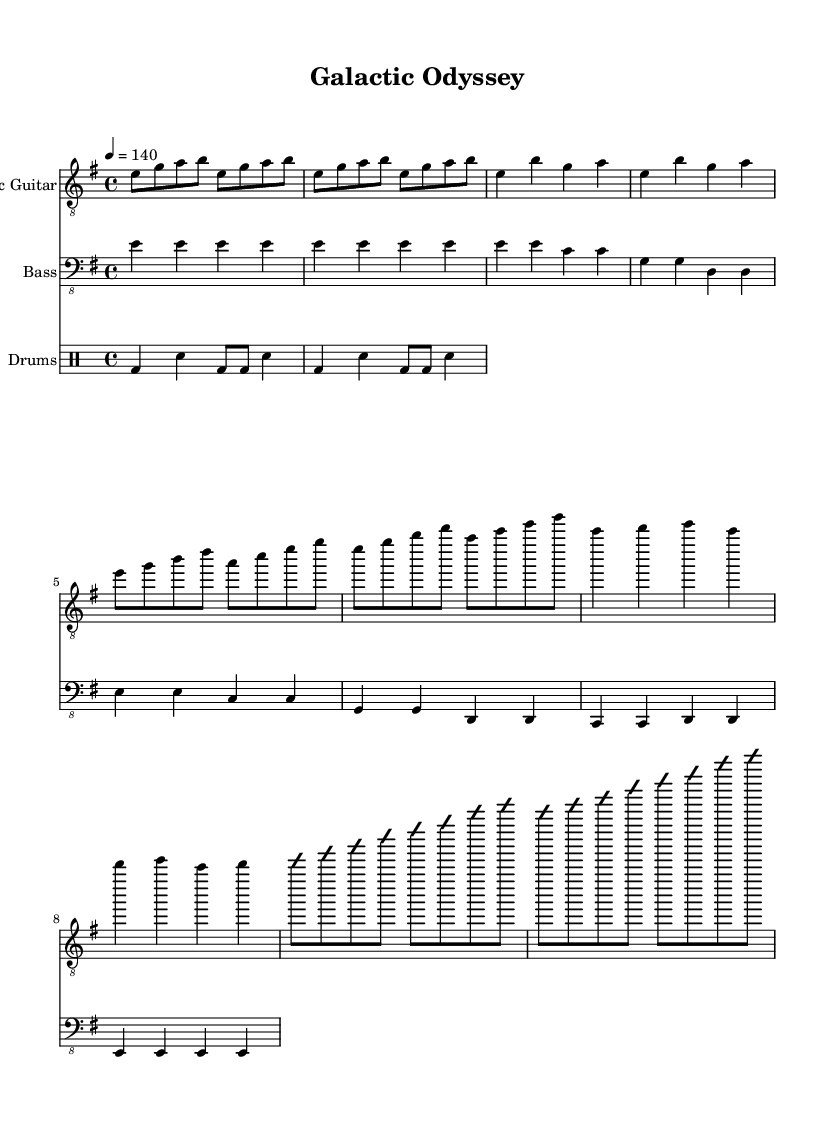What is the key signature of this music? The key is E minor, which is indicated by one sharp (F#) in the key signature.
Answer: E minor What is the time signature of this music? The time signature is found at the beginning of the music, showing 4 beats per measure, indicated by 4/4.
Answer: 4/4 What is the tempo marking for this piece? The tempo marking is indicated at the beginning with "4 = 140", meaning there are 140 beats per minute.
Answer: 140 How many measures are there in the chorus? The chorus includes two measures, as shown in the note representation provided.
Answer: 2 Which instrument primarily plays the melody? The electric guitar plays the melody throughout the piece, as indicated by the corresponding staff notation.
Answer: Electric Guitar What type of drum beat is used in the song? The drum pattern reflects a basic rock beat, characterized by the bass and snare rhythms present in the drum staff.
Answer: Basic rock beat What is the general structure of the song? The song consists of an intro, verse, chorus, bridge, and a solo improvisation section, as indicated by the sections laid out in the music.
Answer: Intro, Verse, Chorus, Bridge, Solo 